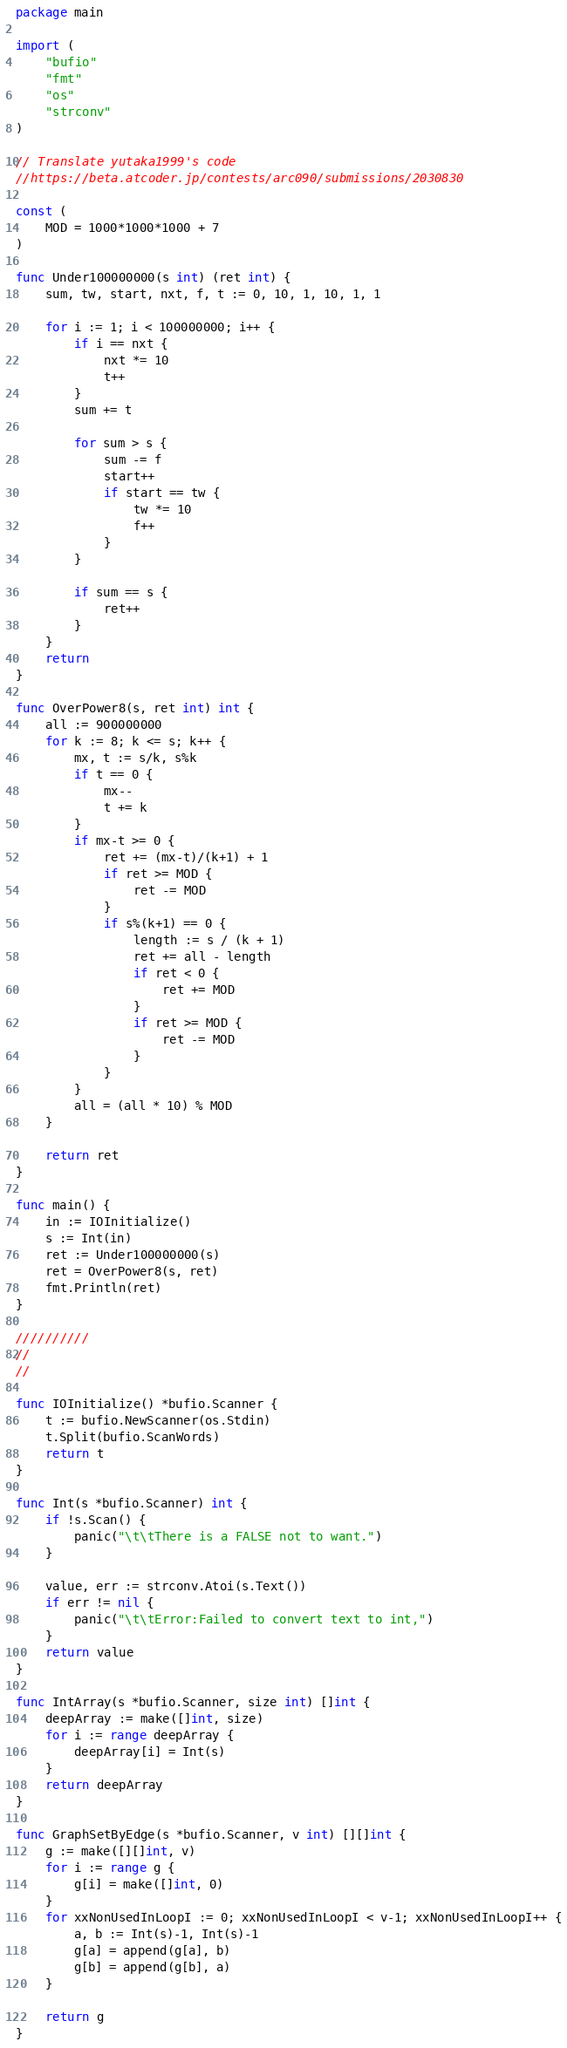<code> <loc_0><loc_0><loc_500><loc_500><_Go_>package main

import (
	"bufio"
	"fmt"
	"os"
	"strconv"
)

// Translate yutaka1999's code
//https://beta.atcoder.jp/contests/arc090/submissions/2030830

const (
	MOD = 1000*1000*1000 + 7
)

func Under100000000(s int) (ret int) {
	sum, tw, start, nxt, f, t := 0, 10, 1, 10, 1, 1

	for i := 1; i < 100000000; i++ {
		if i == nxt {
			nxt *= 10
			t++
		}
		sum += t

		for sum > s {
			sum -= f
			start++
			if start == tw {
				tw *= 10
				f++
			}
		}

		if sum == s {
			ret++
		}
	}
	return
}

func OverPower8(s, ret int) int {
	all := 900000000
	for k := 8; k <= s; k++ {
		mx, t := s/k, s%k
		if t == 0 {
			mx--
			t += k
		}
		if mx-t >= 0 {
			ret += (mx-t)/(k+1) + 1
			if ret >= MOD {
				ret -= MOD
			}
			if s%(k+1) == 0 {
				length := s / (k + 1)
				ret += all - length
				if ret < 0 {
					ret += MOD
				}
				if ret >= MOD {
					ret -= MOD
				}
			}
		}
		all = (all * 10) % MOD
	}

	return ret
}

func main() {
	in := IOInitialize()
	s := Int(in)
	ret := Under100000000(s)
	ret = OverPower8(s, ret)
	fmt.Println(ret)
}

//////////
//
//

func IOInitialize() *bufio.Scanner {
	t := bufio.NewScanner(os.Stdin)
	t.Split(bufio.ScanWords)
	return t
}

func Int(s *bufio.Scanner) int {
	if !s.Scan() {
		panic("\t\tThere is a FALSE not to want.")
	}

	value, err := strconv.Atoi(s.Text())
	if err != nil {
		panic("\t\tError:Failed to convert text to int,")
	}
	return value
}

func IntArray(s *bufio.Scanner, size int) []int {
	deepArray := make([]int, size)
	for i := range deepArray {
		deepArray[i] = Int(s)
	}
	return deepArray
}

func GraphSetByEdge(s *bufio.Scanner, v int) [][]int {
	g := make([][]int, v)
	for i := range g {
		g[i] = make([]int, 0)
	}
	for xxNonUsedInLoopI := 0; xxNonUsedInLoopI < v-1; xxNonUsedInLoopI++ {
		a, b := Int(s)-1, Int(s)-1
		g[a] = append(g[a], b)
		g[b] = append(g[b], a)
	}

	return g
}
</code> 